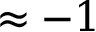<formula> <loc_0><loc_0><loc_500><loc_500>\approx - 1</formula> 